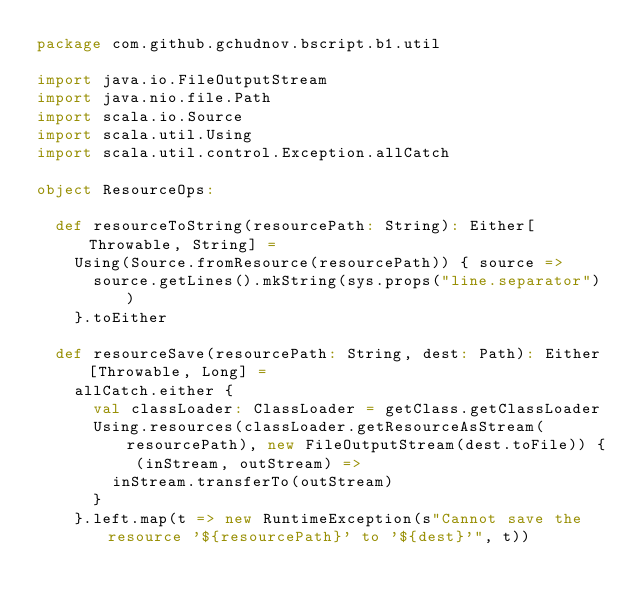<code> <loc_0><loc_0><loc_500><loc_500><_Scala_>package com.github.gchudnov.bscript.b1.util

import java.io.FileOutputStream
import java.nio.file.Path
import scala.io.Source
import scala.util.Using
import scala.util.control.Exception.allCatch

object ResourceOps:

  def resourceToString(resourcePath: String): Either[Throwable, String] =
    Using(Source.fromResource(resourcePath)) { source =>
      source.getLines().mkString(sys.props("line.separator"))
    }.toEither

  def resourceSave(resourcePath: String, dest: Path): Either[Throwable, Long] =
    allCatch.either {
      val classLoader: ClassLoader = getClass.getClassLoader
      Using.resources(classLoader.getResourceAsStream(resourcePath), new FileOutputStream(dest.toFile)) { (inStream, outStream) =>
        inStream.transferTo(outStream)
      }
    }.left.map(t => new RuntimeException(s"Cannot save the resource '${resourcePath}' to '${dest}'", t))
</code> 